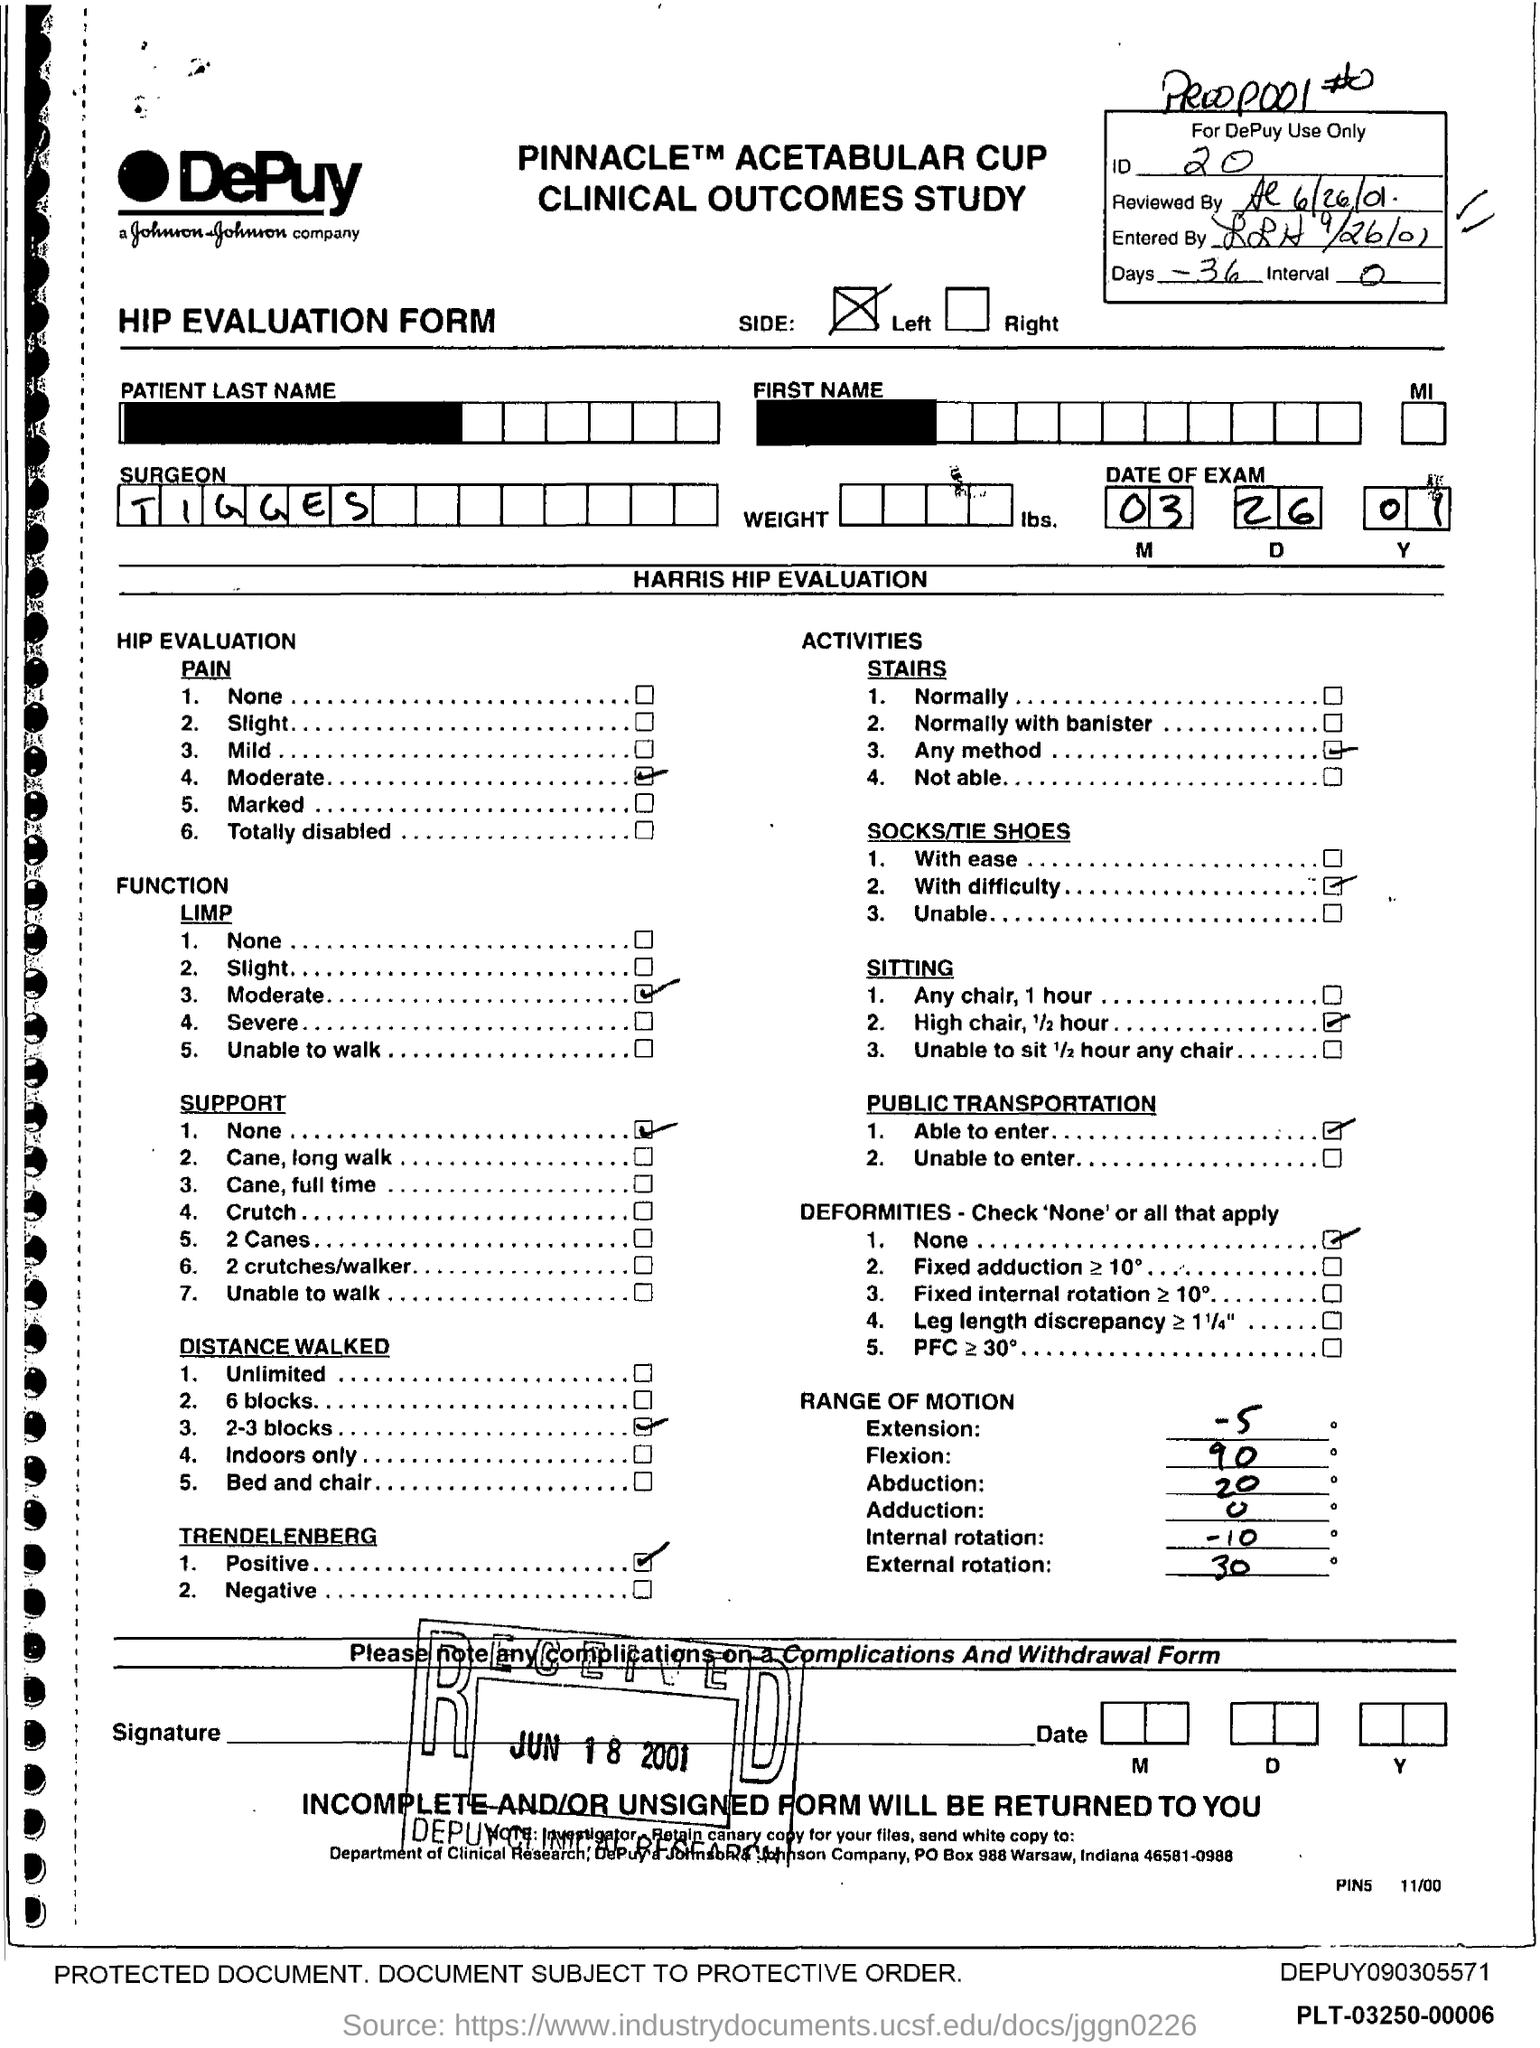What is the ID mentioned in the form?
Keep it short and to the point. 20. What is the no of days given in the form?
Keep it short and to the point. 36. What is the interval mentioned in the form?
Offer a very short reply. 0. What is the date of the exam given in the form?
Make the answer very short. 03.26.01. What is the surgeon name mentioned in the form?
Your response must be concise. TIGGES. What type of form is this?
Offer a very short reply. HIP EVALUATION FORM. What is the received date of the form?
Keep it short and to the point. JUN 18 2001. 